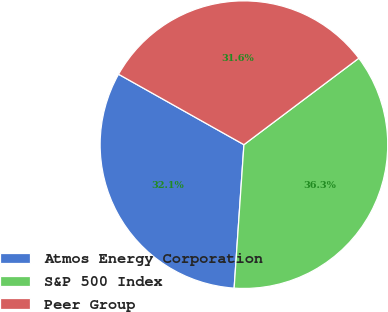Convert chart. <chart><loc_0><loc_0><loc_500><loc_500><pie_chart><fcel>Atmos Energy Corporation<fcel>S&P 500 Index<fcel>Peer Group<nl><fcel>32.06%<fcel>36.35%<fcel>31.59%<nl></chart> 